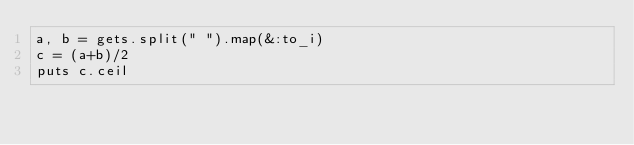<code> <loc_0><loc_0><loc_500><loc_500><_Ruby_>a, b = gets.split(" ").map(&:to_i)
c = (a+b)/2
puts c.ceil</code> 